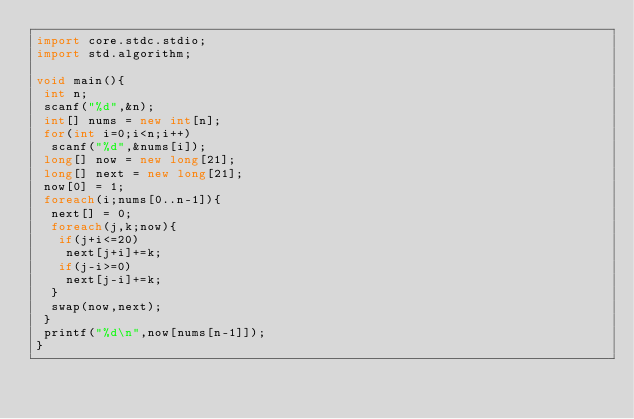Convert code to text. <code><loc_0><loc_0><loc_500><loc_500><_D_>import core.stdc.stdio;
import std.algorithm;
 
void main(){
 int n;
 scanf("%d",&n);
 int[] nums = new int[n];
 for(int i=0;i<n;i++)
  scanf("%d",&nums[i]);
 long[] now = new long[21];
 long[] next = new long[21];
 now[0] = 1;
 foreach(i;nums[0..n-1]){
  next[] = 0;
  foreach(j,k;now){
   if(j+i<=20)
    next[j+i]+=k;
   if(j-i>=0)
    next[j-i]+=k;
  }
  swap(now,next);
 }
 printf("%d\n",now[nums[n-1]]);
}</code> 